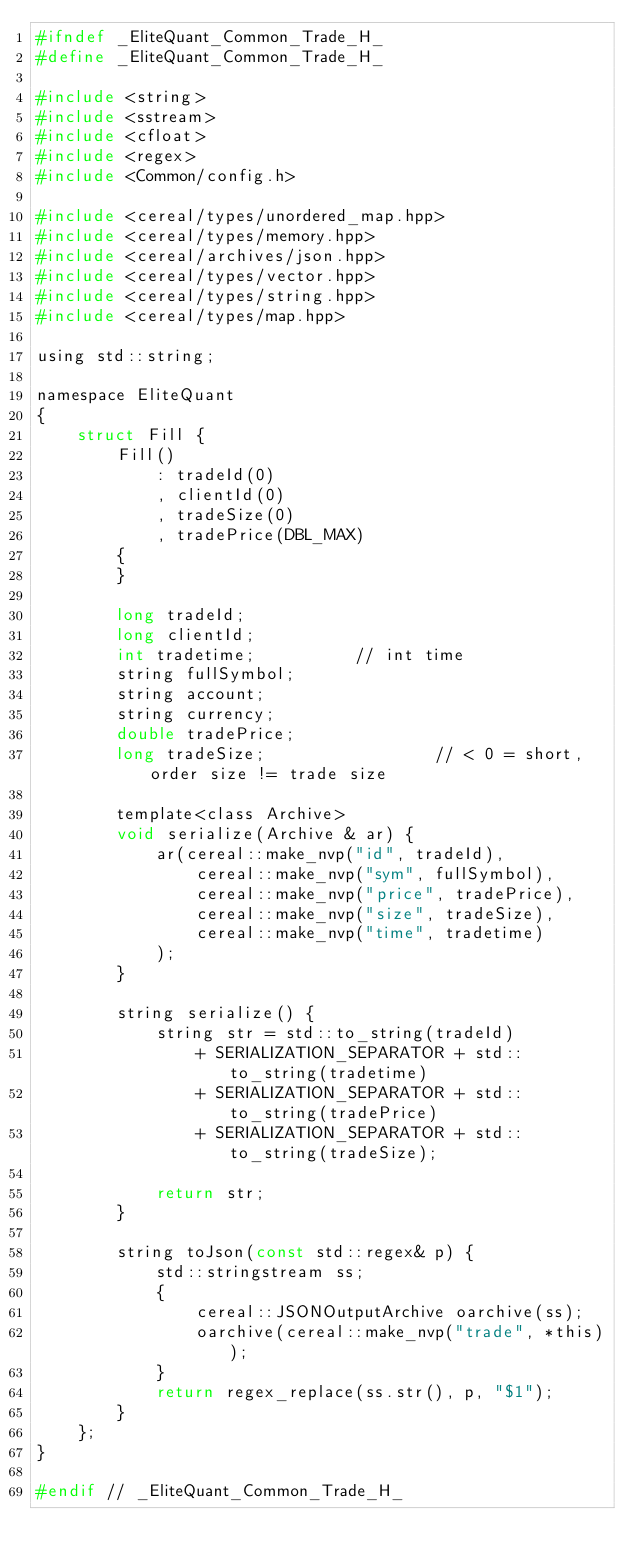Convert code to text. <code><loc_0><loc_0><loc_500><loc_500><_C_>#ifndef _EliteQuant_Common_Trade_H_
#define _EliteQuant_Common_Trade_H_

#include <string>
#include <sstream>
#include <cfloat>
#include <regex>
#include <Common/config.h>

#include <cereal/types/unordered_map.hpp>
#include <cereal/types/memory.hpp>
#include <cereal/archives/json.hpp>
#include <cereal/types/vector.hpp>
#include <cereal/types/string.hpp>
#include <cereal/types/map.hpp>

using std::string;

namespace EliteQuant
{
	struct Fill {
		Fill()
			: tradeId(0)
			, clientId(0)
			, tradeSize(0)
			, tradePrice(DBL_MAX)
		{
		}

		long tradeId;
		long clientId;
		int tradetime;			// int time
		string fullSymbol;
		string account;
		string currency;
		double tradePrice;
		long tradeSize;					// < 0 = short, order size != trade size

		template<class Archive>
		void serialize(Archive & ar) {
			ar(cereal::make_nvp("id", tradeId),
				cereal::make_nvp("sym", fullSymbol),
				cereal::make_nvp("price", tradePrice),
				cereal::make_nvp("size", tradeSize),
				cereal::make_nvp("time", tradetime)
			);
		}

		string serialize() {
			string str = std::to_string(tradeId)
				+ SERIALIZATION_SEPARATOR + std::to_string(tradetime)
				+ SERIALIZATION_SEPARATOR + std::to_string(tradePrice)
				+ SERIALIZATION_SEPARATOR + std::to_string(tradeSize);

			return str;
		}

		string toJson(const std::regex& p) {
			std::stringstream ss;
			{
				cereal::JSONOutputArchive oarchive(ss);
				oarchive(cereal::make_nvp("trade", *this));
			}
			return regex_replace(ss.str(), p, "$1");
		}
	};
}

#endif // _EliteQuant_Common_Trade_H_
</code> 